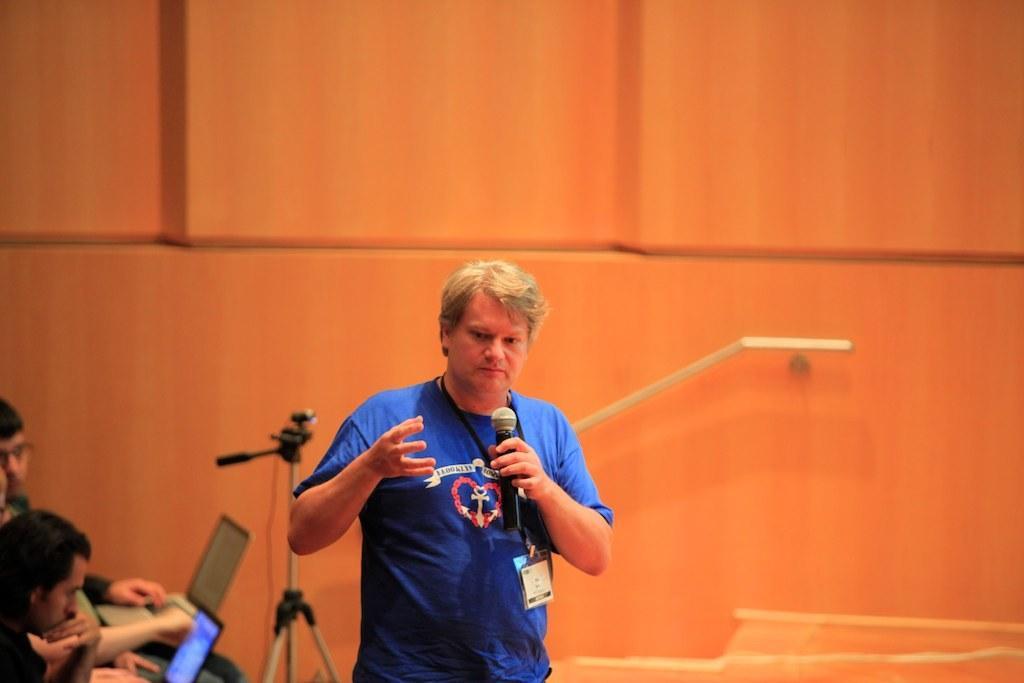Please provide a concise description of this image. In the foreground, I can see one person is holding a mike in hand and two persons are sitting on the chairs and are holding laptops in their hand. In the background, I can see a camera stand and a wall. This image is taken, maybe in a hall. 